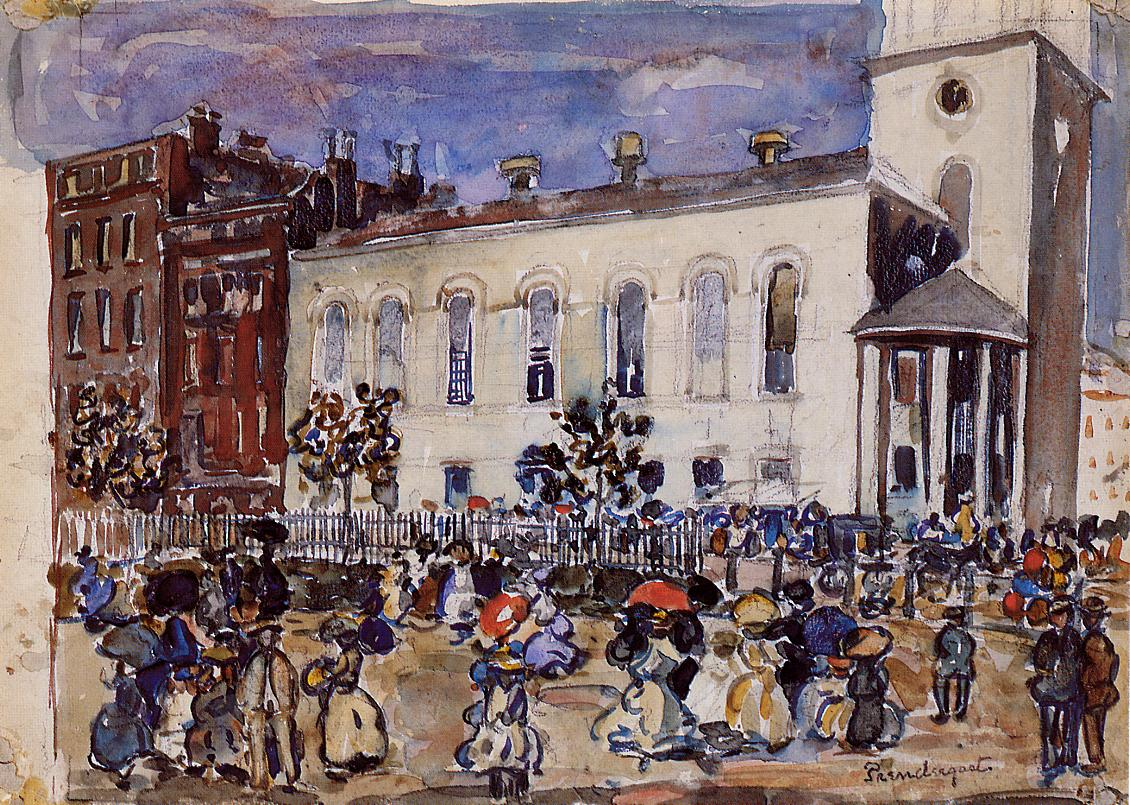Can you elaborate on the elements of the picture provided? Absolutely, the image presents an impressionist street scene teeming with life. It captures the essence of an early 20th-century urban setting with figures engaging in daily activities like walking and conversing. Each figure is rendered with brisk yet thoughtful brushstrokes, imbuing the scene with a sense of motion and vitality. The backdrop features classical architecture, including a prominent white building with a tall columned tower. Its historical presence contrasts with the transient nature of the people in the foreground, suggesting a narrative of everyday life unfolding against the backdrop of enduring structures. The painting's palette is primarily composed of harmonious earth tones complemented by touches of blue and green, instilling the canvas with depth and inviting the viewer to ponder the interplay between light, color, and texture. 